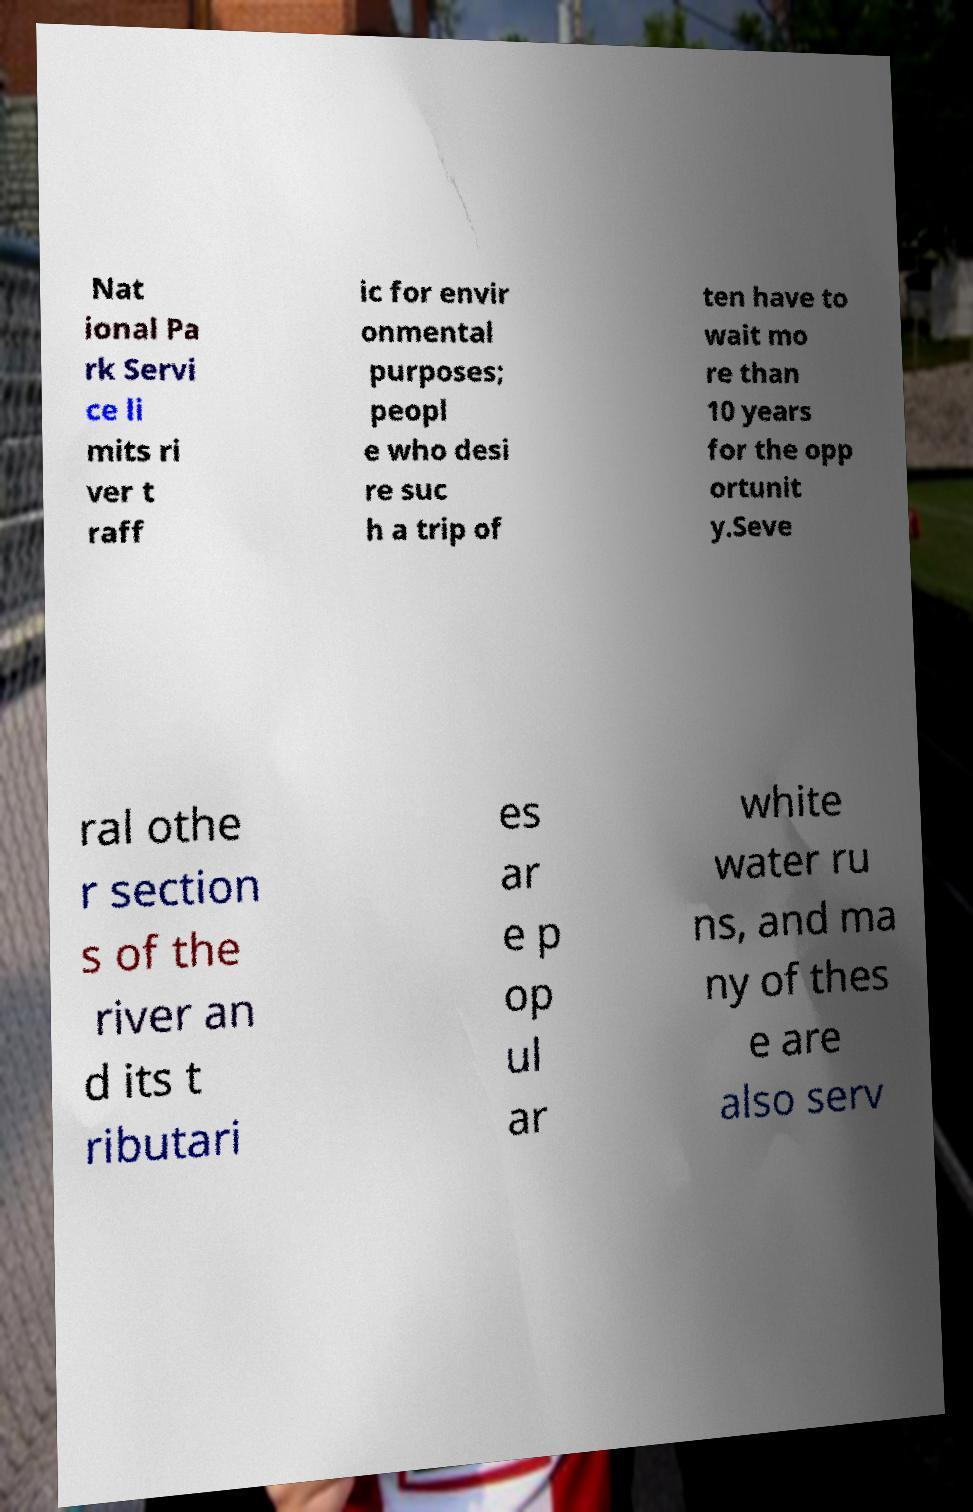Could you extract and type out the text from this image? Nat ional Pa rk Servi ce li mits ri ver t raff ic for envir onmental purposes; peopl e who desi re suc h a trip of ten have to wait mo re than 10 years for the opp ortunit y.Seve ral othe r section s of the river an d its t ributari es ar e p op ul ar white water ru ns, and ma ny of thes e are also serv 